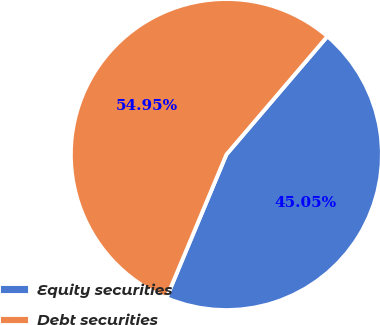Convert chart to OTSL. <chart><loc_0><loc_0><loc_500><loc_500><pie_chart><fcel>Equity securities<fcel>Debt securities<nl><fcel>45.05%<fcel>54.95%<nl></chart> 